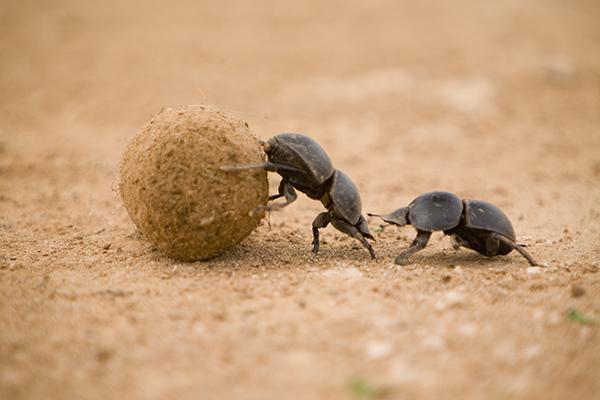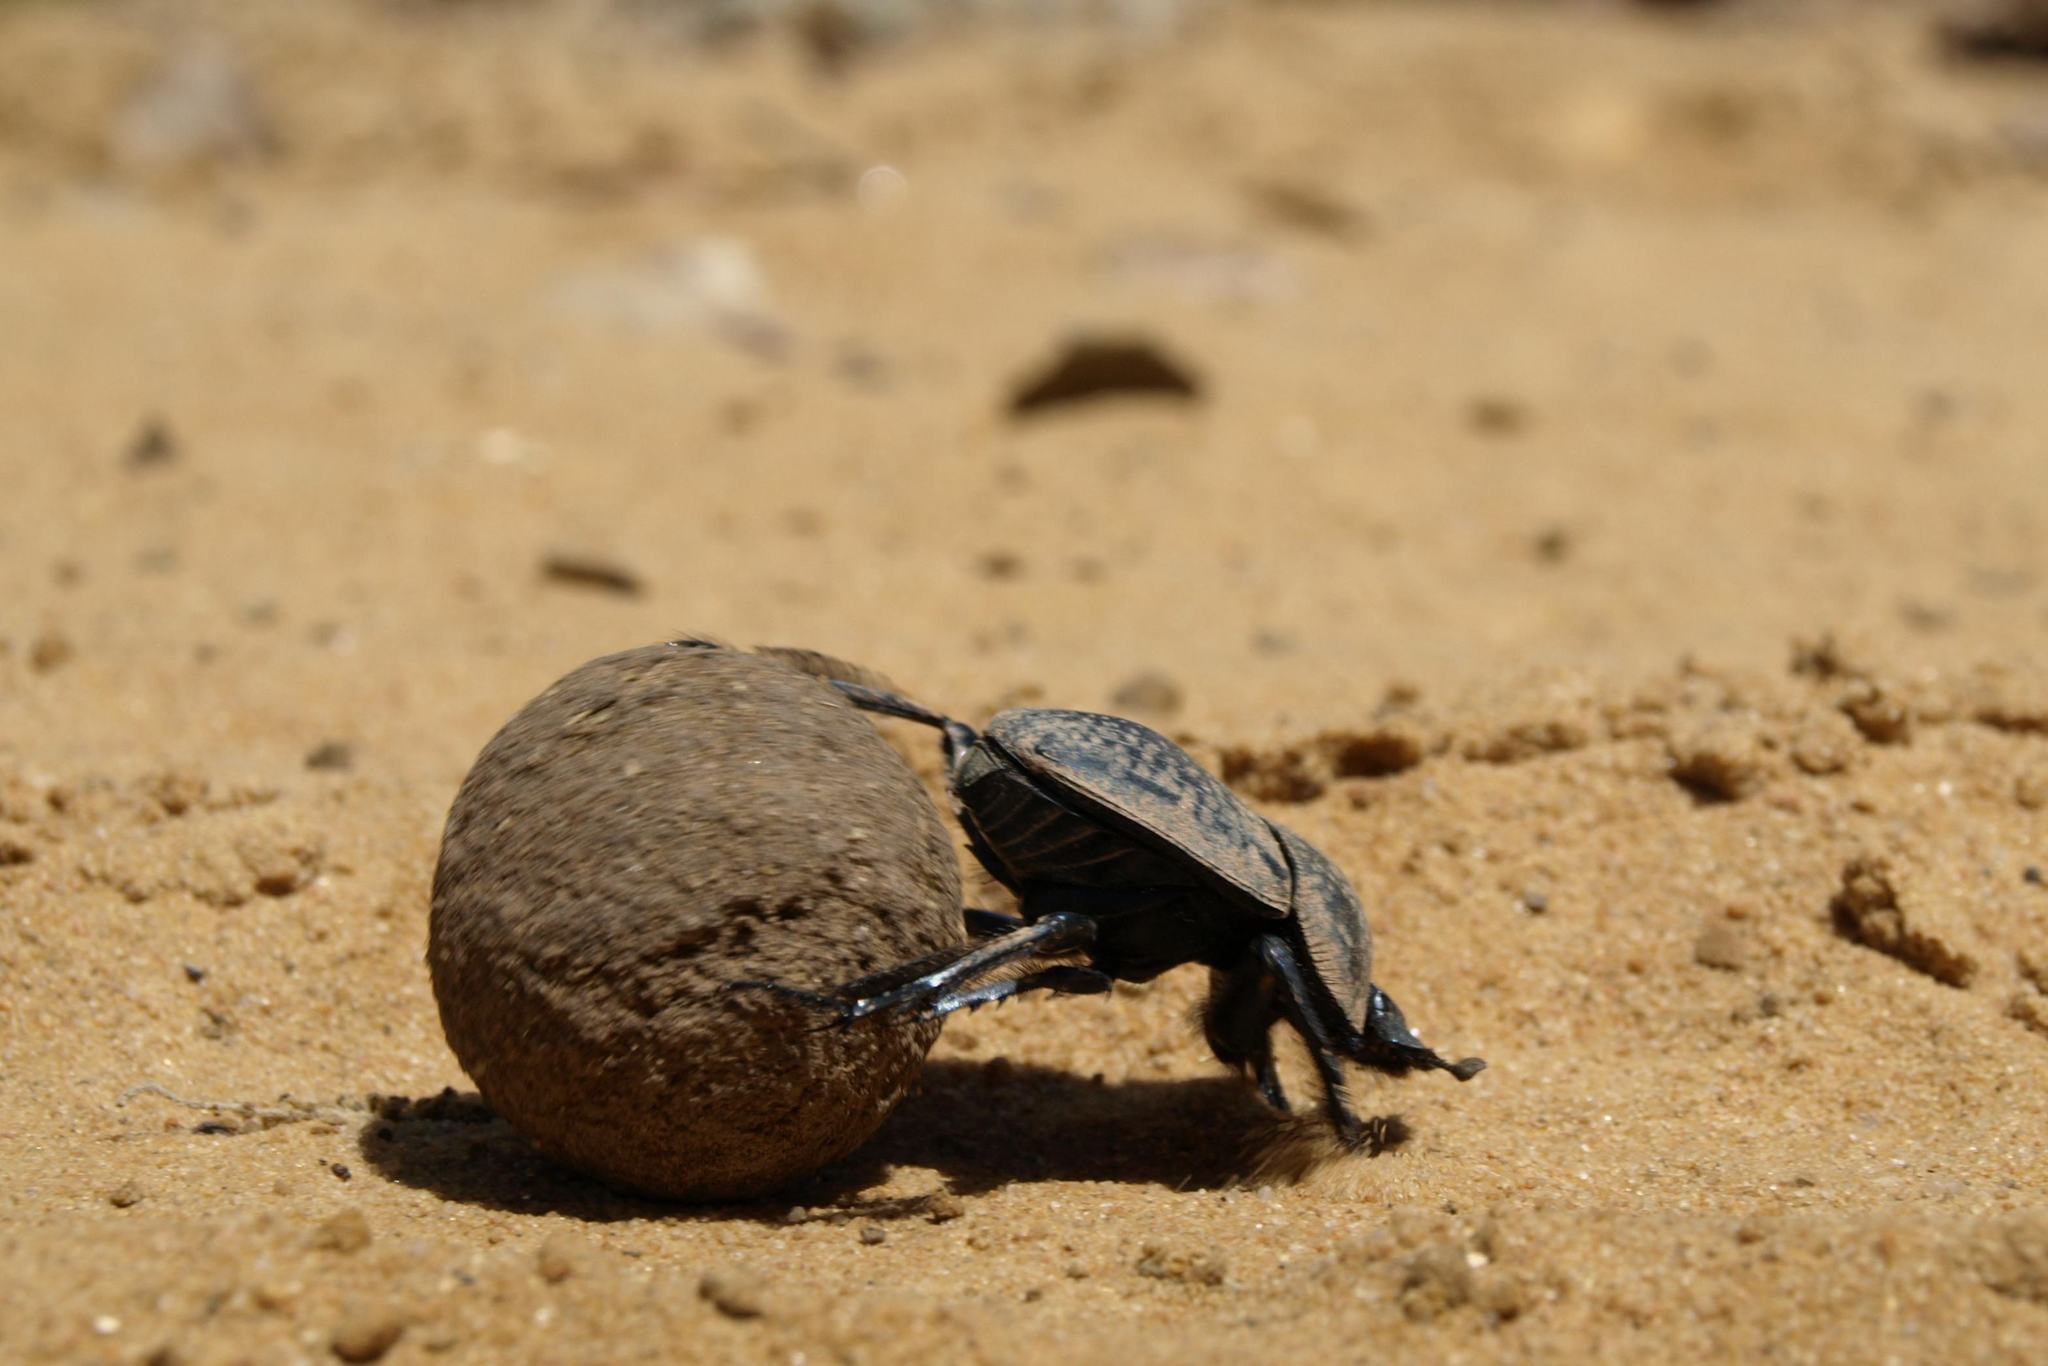The first image is the image on the left, the second image is the image on the right. Assess this claim about the two images: "There are two beetles touching a dungball.". Correct or not? Answer yes or no. Yes. 